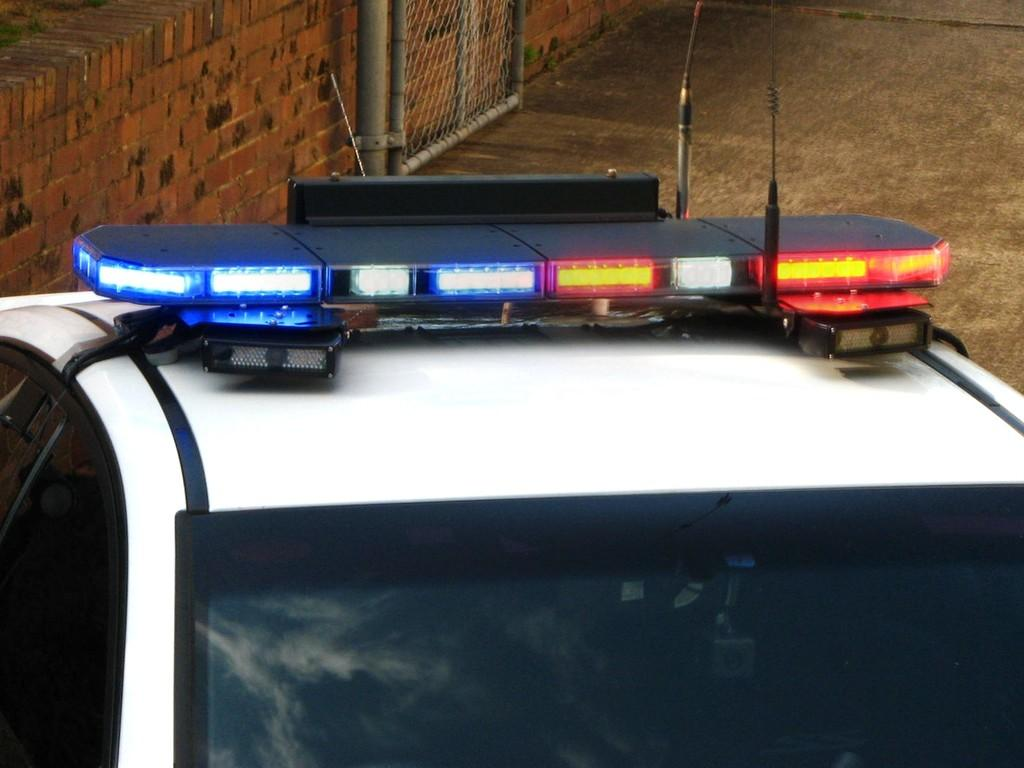What is the main subject in the foreground of the image? There is a car in the foreground of the image. What feature can be seen on top of the car? There are lights on top of the car. What can be seen in the background of the image? There is a wall and a gate in the background of the image. What is visible beneath the car and other objects in the image? The ground is visible in the image. What type of dirt can be seen on the scissors in the image? There are no scissors present in the image, so it is not possible to determine if there is any dirt on them. What type of farm animals can be seen in the image? There are no farm animals present in the image; it features a car, lights, a wall, a gate, and the ground. 